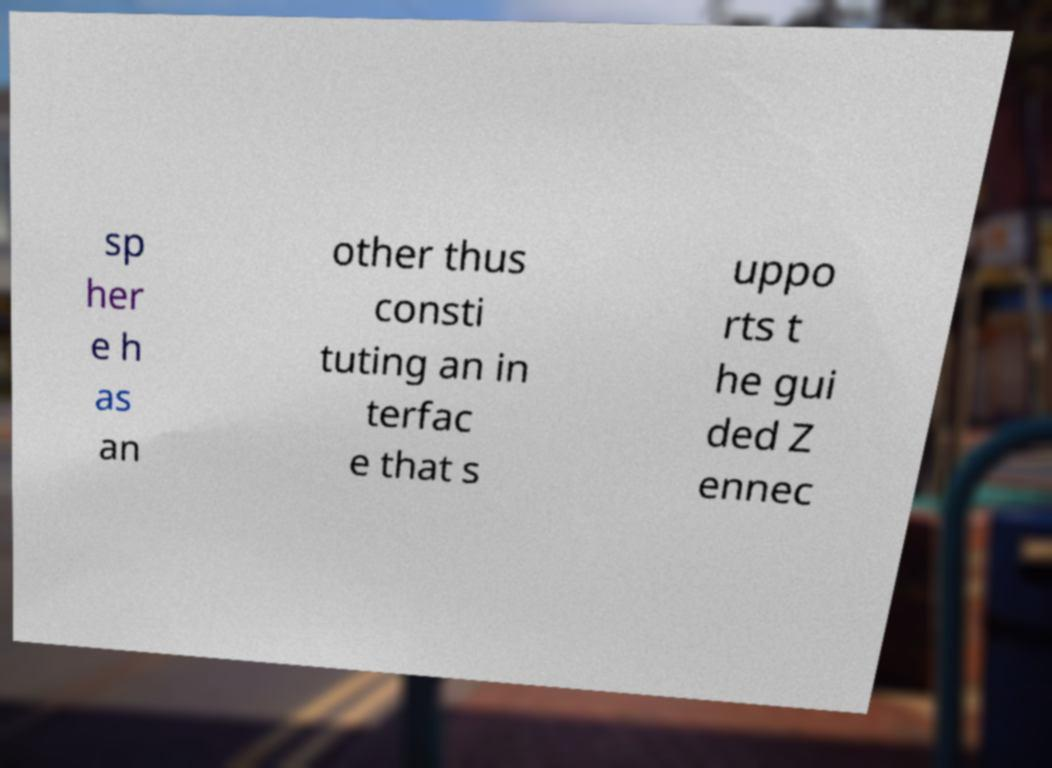Can you read and provide the text displayed in the image?This photo seems to have some interesting text. Can you extract and type it out for me? sp her e h as an other thus consti tuting an in terfac e that s uppo rts t he gui ded Z ennec 